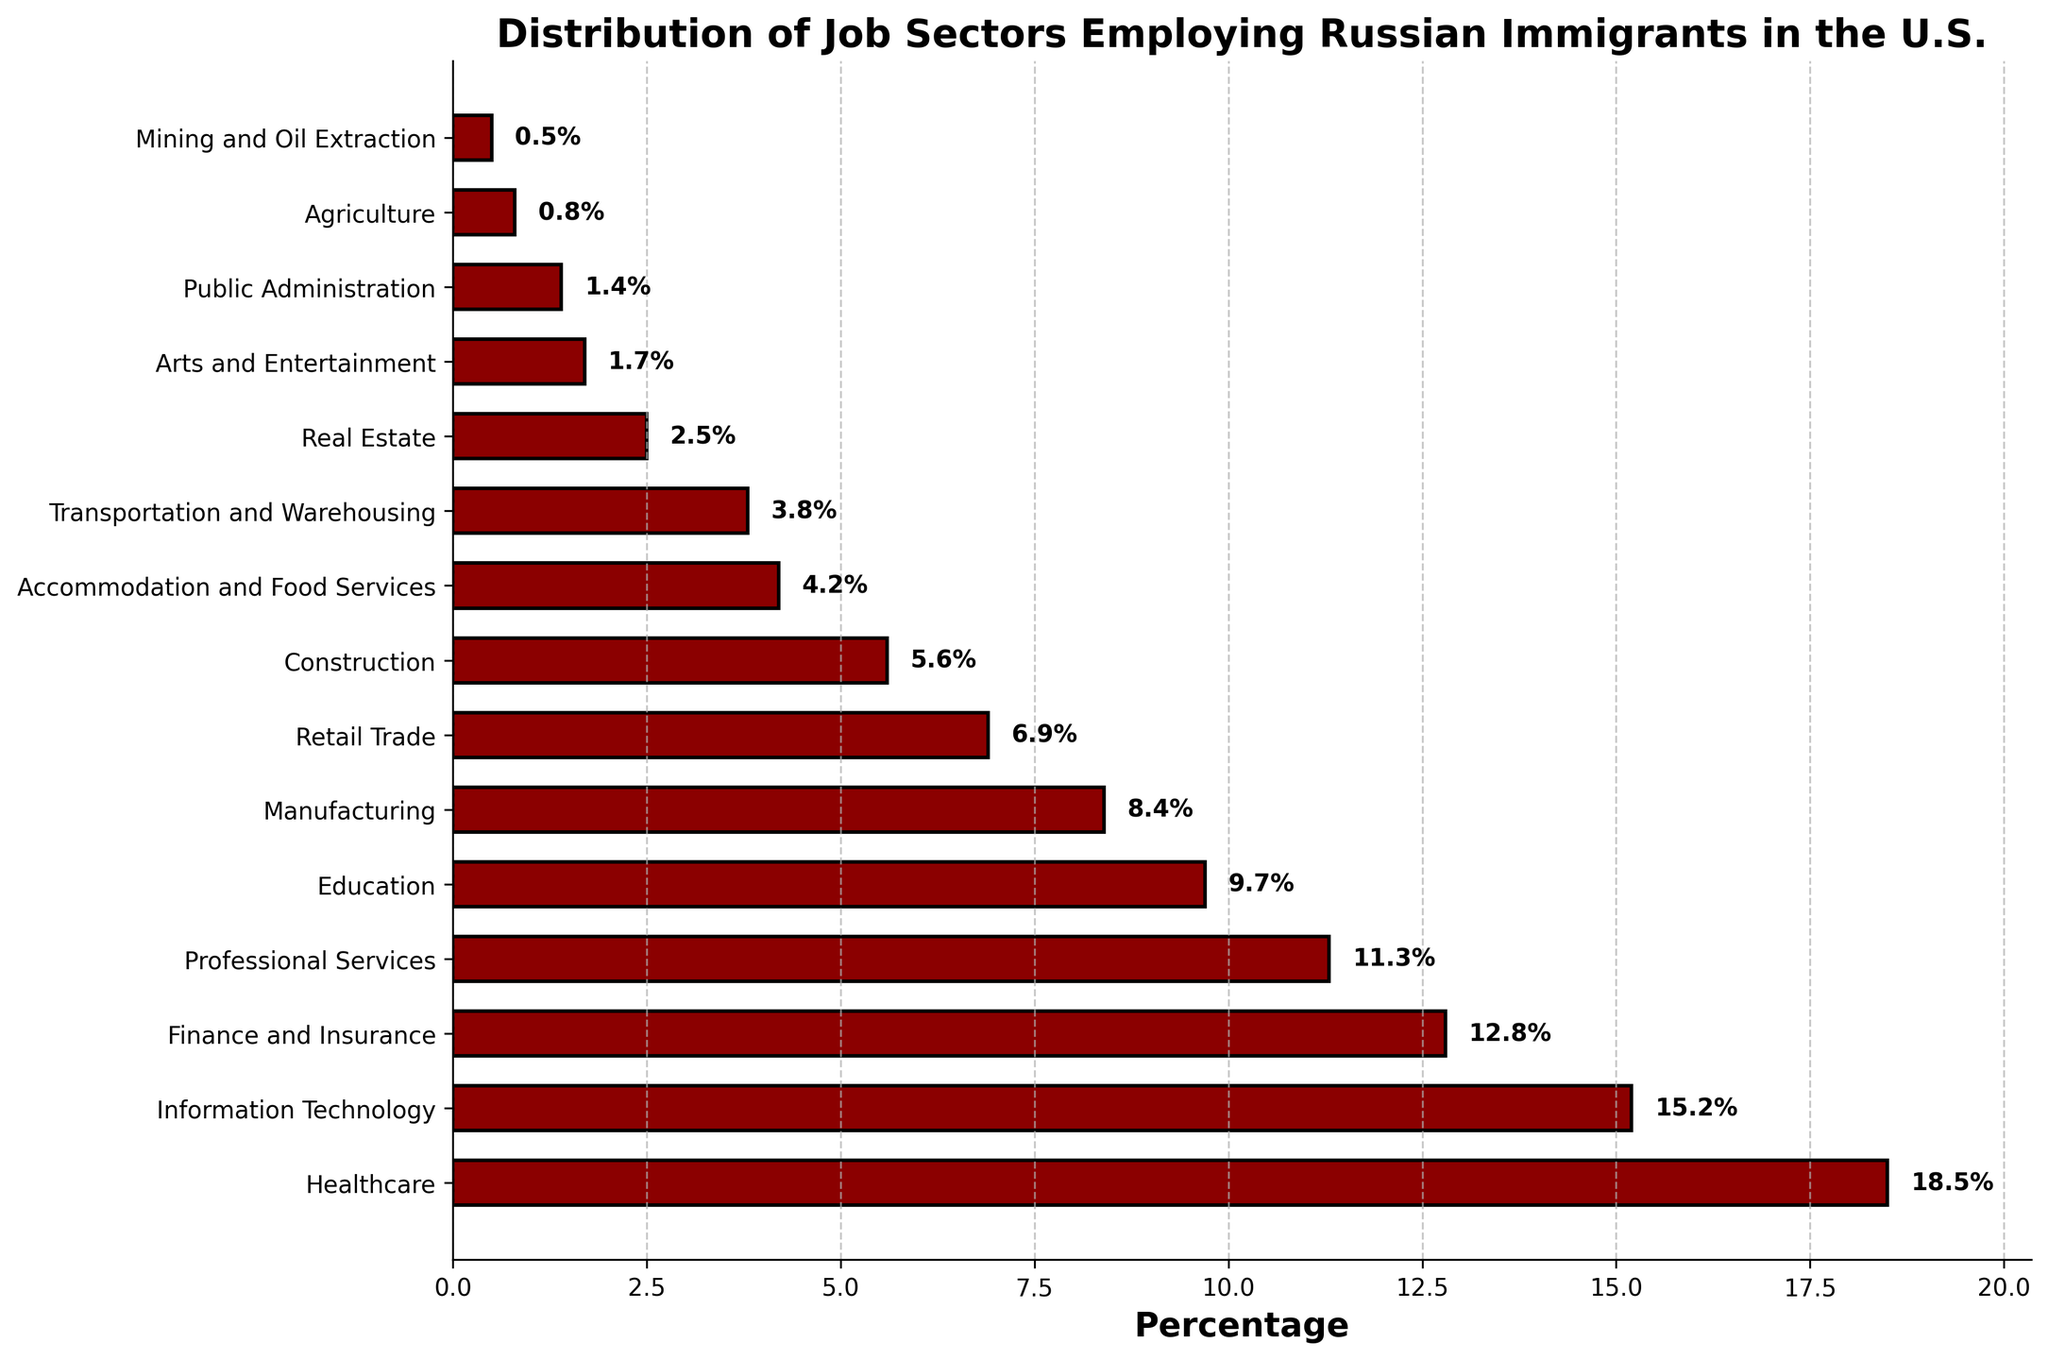What industry employs the highest percentage of Russian immigrants? The bar representing Healthcare is the longest, and the percentage noted on the bar is 18.5%.
Answer: Healthcare Which sector employs more Russian immigrants, Information Technology or Finance and Insurance? Information Technology has a percentage of 15.2%, which is higher than Finance and Insurance at 12.8%.
Answer: Information Technology What is the difference in the employment rates between the Healthcare and Mining and Oil Extraction industries? Healthcare employs 18.5%, while Mining and Oil Extraction employs 0.5%. The difference is 18.5% - 0.5% = 18%.
Answer: 18% Which sector employs the least percentage of Russian immigrants? The shortest bar represents the Mining and Oil Extraction industry, with a percentage of 0.5%.
Answer: Mining and Oil Extraction How many industries employ more than 10% of Russian immigrants? The bars for Healthcare (18.5%), Information Technology (15.2%), Finance and Insurance (12.8%), and Professional Services (11.3%) are above the 10% mark. There are 4 such industries.
Answer: 4 Compare the employment percentages of the Education and Retail Trade sectors. Which one is higher and by how much? Education employs 9.7%, and Retail Trade employs 6.9%. The difference is 9.7% - 6.9% = 2.8%. Education is higher.
Answer: Education is higher by 2.8% What is the total employment percentage for the top three industries? The top three industries by percentage are Healthcare (18.5%), Information Technology (15.2%), and Finance and Insurance (12.8%). The total is 18.5% + 15.2% + 12.8% = 46.5%.
Answer: 46.5% Among the sectors listed, how many employ less than 5% of Russian immigrants? The bars representing sectors below 5% are Transportation and Warehousing (3.8%), Real Estate (2.5%), Arts and Entertainment (1.7%), Public Administration (1.4%), Agriculture (0.8%), and Mining and Oil Extraction (0.5%). There are 6 such sectors.
Answer: 6 Is the percentage of Russian immigrants employed in Construction higher than in Manufacturing? No, Construction employs 5.6%, while Manufacturing employs 8.4%.
Answer: No What is the average employment percentage for Accommodation and Food Services, Real Estate, and Public Administration industries? Adding the percentages for these sectors: 4.2% + 2.5% + 1.4% = 8.1%. Dividing by the number of sectors, 8.1% / 3 = 2.7%.
Answer: 2.7% 